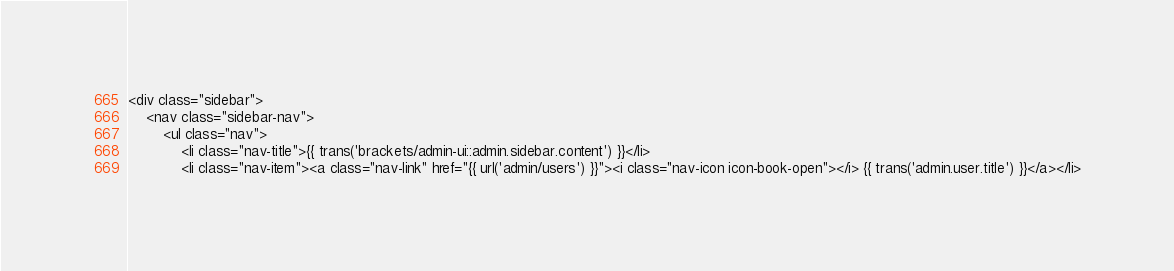Convert code to text. <code><loc_0><loc_0><loc_500><loc_500><_PHP_><div class="sidebar">
    <nav class="sidebar-nav">
        <ul class="nav">
            <li class="nav-title">{{ trans('brackets/admin-ui::admin.sidebar.content') }}</li>
            <li class="nav-item"><a class="nav-link" href="{{ url('admin/users') }}"><i class="nav-icon icon-book-open"></i> {{ trans('admin.user.title') }}</a></li></code> 